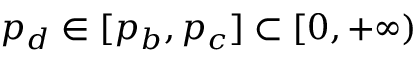<formula> <loc_0><loc_0><loc_500><loc_500>p _ { d } \in [ p _ { b } , p _ { c } ] \subset [ 0 , + \infty )</formula> 